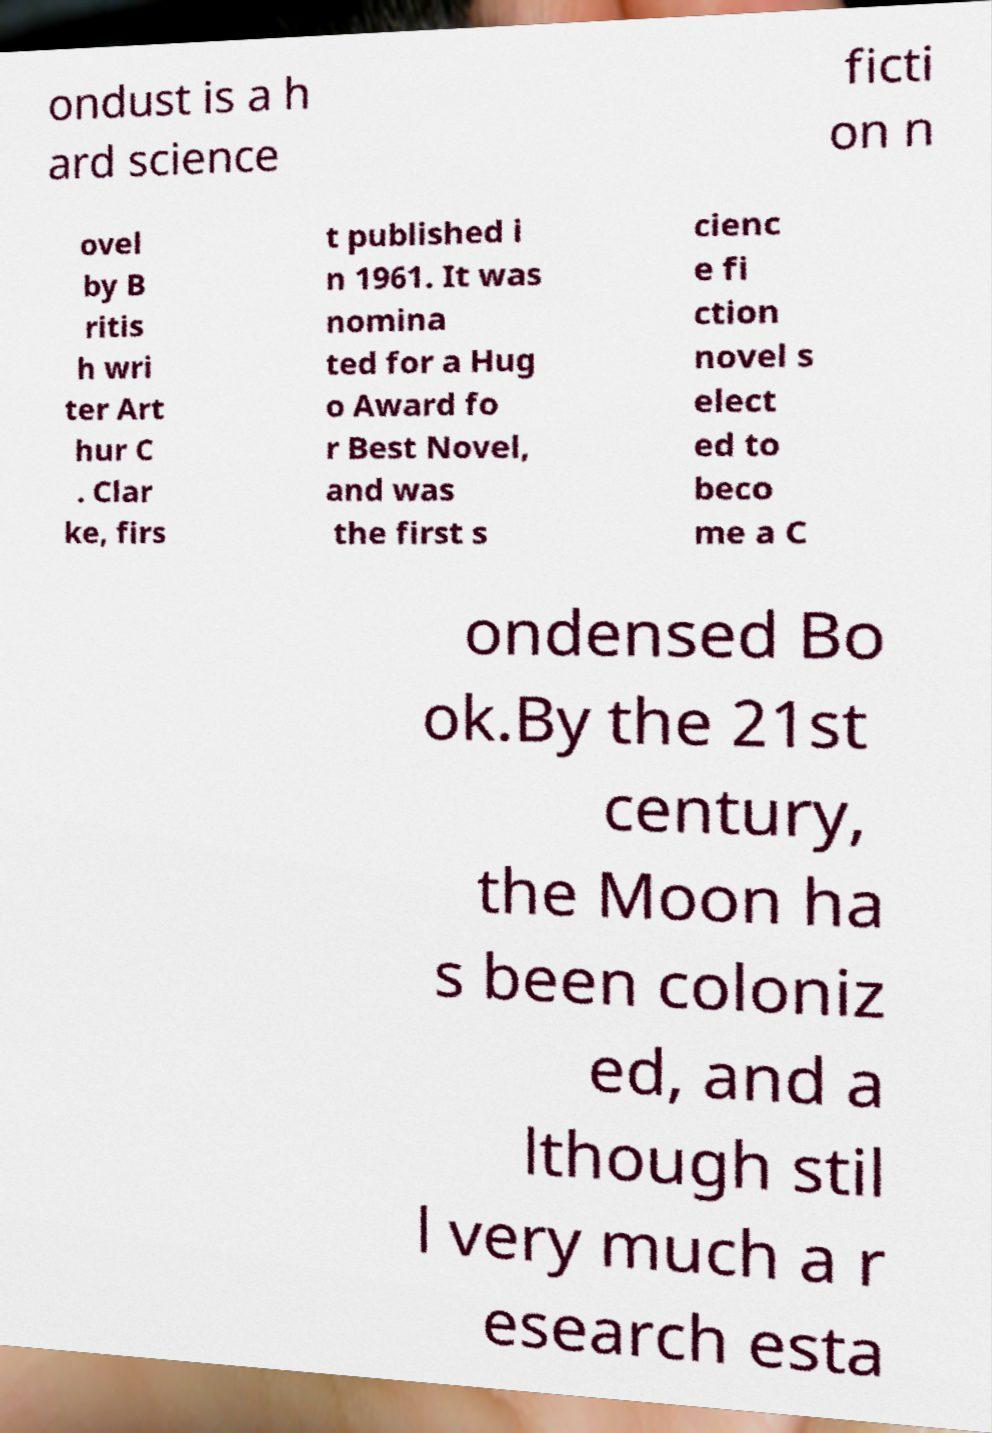Can you accurately transcribe the text from the provided image for me? ondust is a h ard science ficti on n ovel by B ritis h wri ter Art hur C . Clar ke, firs t published i n 1961. It was nomina ted for a Hug o Award fo r Best Novel, and was the first s cienc e fi ction novel s elect ed to beco me a C ondensed Bo ok.By the 21st century, the Moon ha s been coloniz ed, and a lthough stil l very much a r esearch esta 